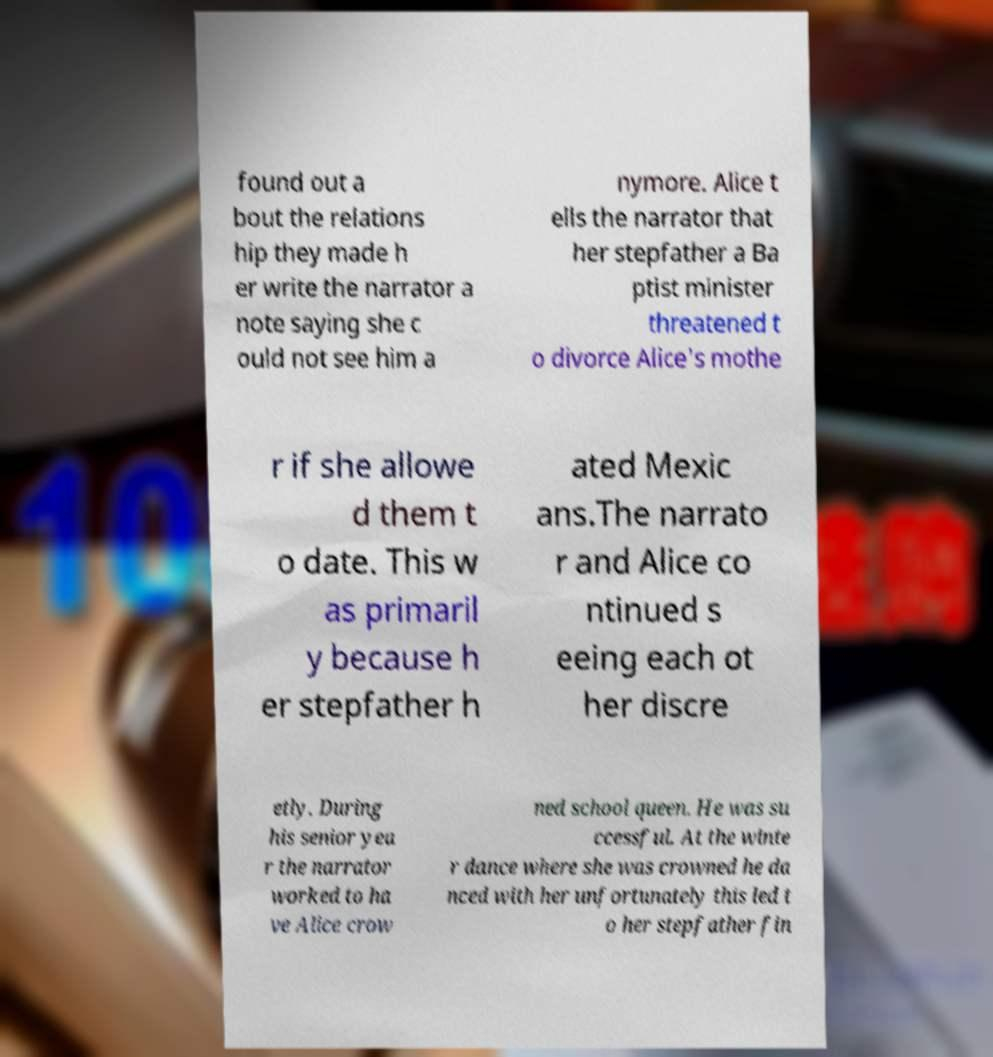Can you read and provide the text displayed in the image?This photo seems to have some interesting text. Can you extract and type it out for me? found out a bout the relations hip they made h er write the narrator a note saying she c ould not see him a nymore. Alice t ells the narrator that her stepfather a Ba ptist minister threatened t o divorce Alice's mothe r if she allowe d them t o date. This w as primaril y because h er stepfather h ated Mexic ans.The narrato r and Alice co ntinued s eeing each ot her discre etly. During his senior yea r the narrator worked to ha ve Alice crow ned school queen. He was su ccessful. At the winte r dance where she was crowned he da nced with her unfortunately this led t o her stepfather fin 